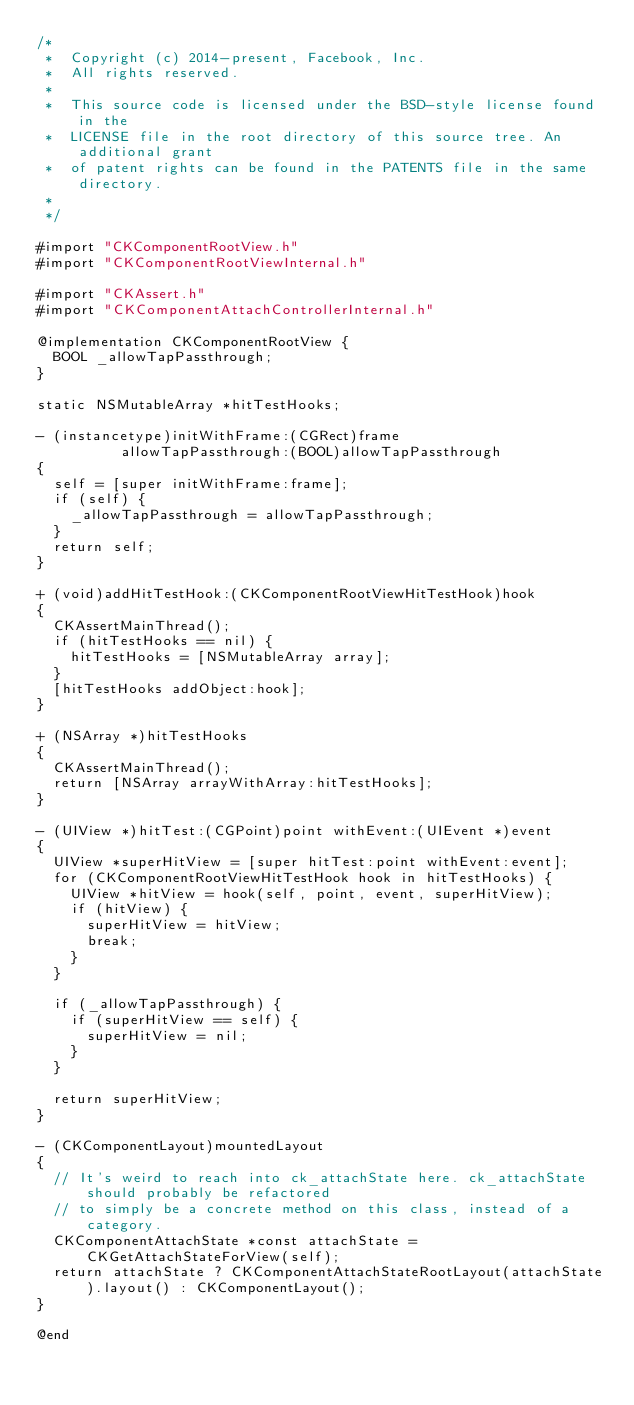Convert code to text. <code><loc_0><loc_0><loc_500><loc_500><_ObjectiveC_>/*
 *  Copyright (c) 2014-present, Facebook, Inc.
 *  All rights reserved.
 *
 *  This source code is licensed under the BSD-style license found in the
 *  LICENSE file in the root directory of this source tree. An additional grant
 *  of patent rights can be found in the PATENTS file in the same directory.
 *
 */

#import "CKComponentRootView.h"
#import "CKComponentRootViewInternal.h"

#import "CKAssert.h"
#import "CKComponentAttachControllerInternal.h"

@implementation CKComponentRootView {
  BOOL _allowTapPassthrough;
}

static NSMutableArray *hitTestHooks;

- (instancetype)initWithFrame:(CGRect)frame
          allowTapPassthrough:(BOOL)allowTapPassthrough
{
  self = [super initWithFrame:frame];
  if (self) {
    _allowTapPassthrough = allowTapPassthrough;
  }
  return self;
}

+ (void)addHitTestHook:(CKComponentRootViewHitTestHook)hook
{
  CKAssertMainThread();
  if (hitTestHooks == nil) {
    hitTestHooks = [NSMutableArray array];
  }
  [hitTestHooks addObject:hook];
}

+ (NSArray *)hitTestHooks
{
  CKAssertMainThread();
  return [NSArray arrayWithArray:hitTestHooks];
}

- (UIView *)hitTest:(CGPoint)point withEvent:(UIEvent *)event
{
  UIView *superHitView = [super hitTest:point withEvent:event];
  for (CKComponentRootViewHitTestHook hook in hitTestHooks) {
    UIView *hitView = hook(self, point, event, superHitView);
    if (hitView) {
      superHitView = hitView;
      break;
    }
  }

  if (_allowTapPassthrough) {
    if (superHitView == self) {
      superHitView = nil;
    }
  }

  return superHitView;
}

- (CKComponentLayout)mountedLayout
{
  // It's weird to reach into ck_attachState here. ck_attachState should probably be refactored
  // to simply be a concrete method on this class, instead of a category.
  CKComponentAttachState *const attachState = CKGetAttachStateForView(self);
  return attachState ? CKComponentAttachStateRootLayout(attachState).layout() : CKComponentLayout();
}

@end
</code> 